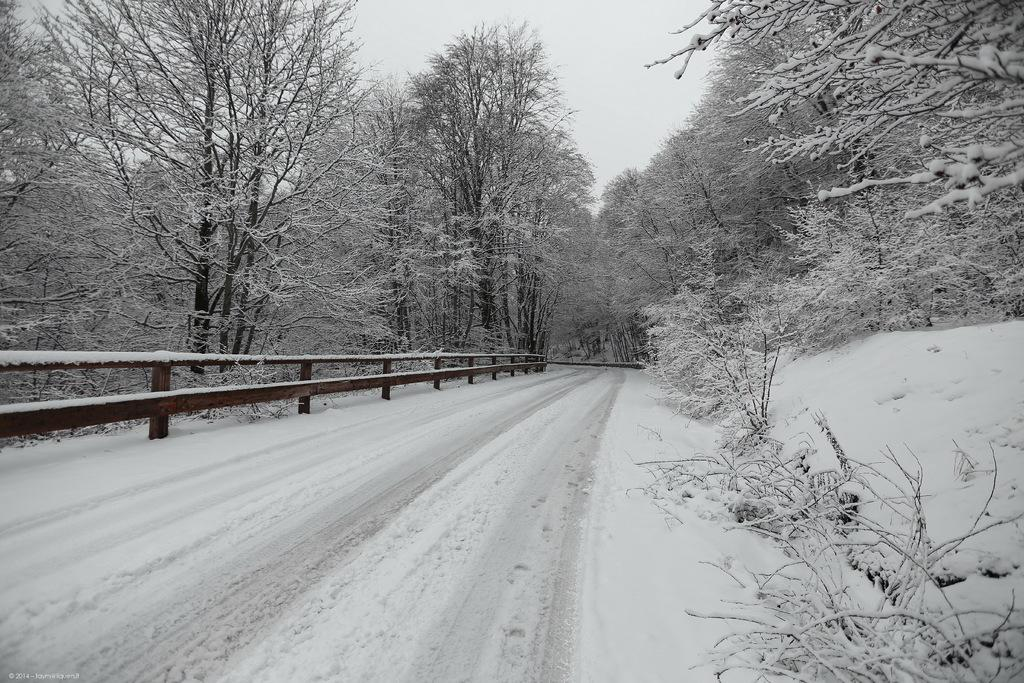What can be seen on the left side of the image? There are trees, plants, snow, and a railing on the left side of the image. What is in the middle of the image? There is a road in the middle of the image. What can be seen on the right side of the image? There are trees, plants, snow, and a railing on the right side of the image. What is visible in the background of the image? The sky is visible in the background of the image. What theory is being tested in the image? There is no theory being tested in the image; it depicts a snowy landscape with trees, plants, a road, and a railing on both sides. How does the scale of the image compare to a real-life scene? The scale of the image cannot be determined from the image itself, as it is a two-dimensional representation of a scene. 